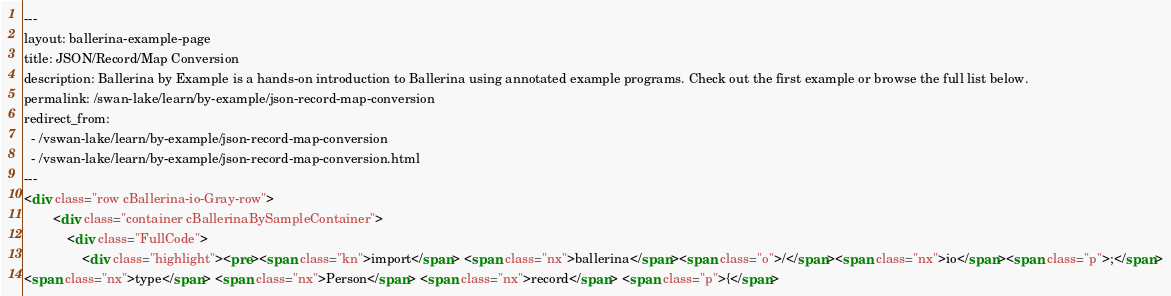Convert code to text. <code><loc_0><loc_0><loc_500><loc_500><_HTML_>---
layout: ballerina-example-page
title: JSON/Record/Map Conversion
description: Ballerina by Example is a hands-on introduction to Ballerina using annotated example programs. Check out the first example or browse the full list below.
permalink: /swan-lake/learn/by-example/json-record-map-conversion
redirect_from:
  - /vswan-lake/learn/by-example/json-record-map-conversion
  - /vswan-lake/learn/by-example/json-record-map-conversion.html
---
<div class="row cBallerina-io-Gray-row">
        <div class="container cBallerinaBySampleContainer">
            <div class="FullCode">
                <div class="highlight"><pre><span class="kn">import</span> <span class="nx">ballerina</span><span class="o">/</span><span class="nx">io</span><span class="p">;</span>
<span class="nx">type</span> <span class="nx">Person</span> <span class="nx">record</span> <span class="p">{</span></code> 